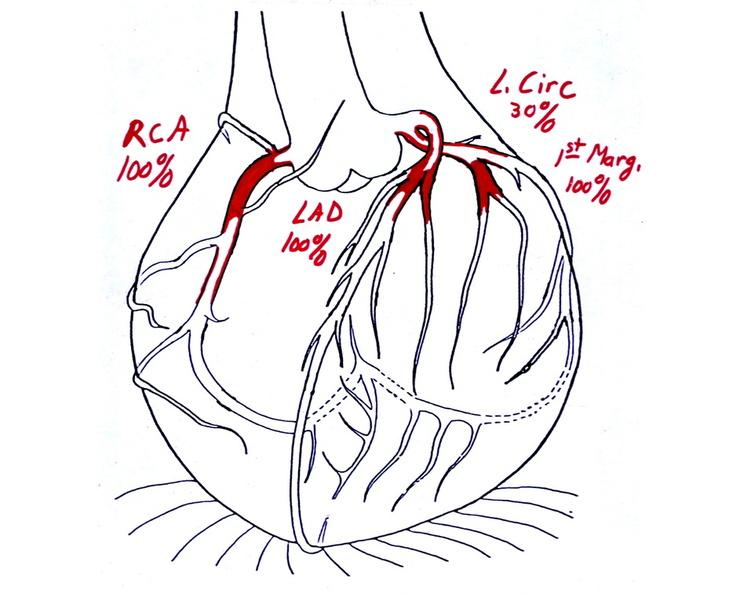does intraductal papillomatosis show coronary artery atherosclerosis diagram?
Answer the question using a single word or phrase. No 